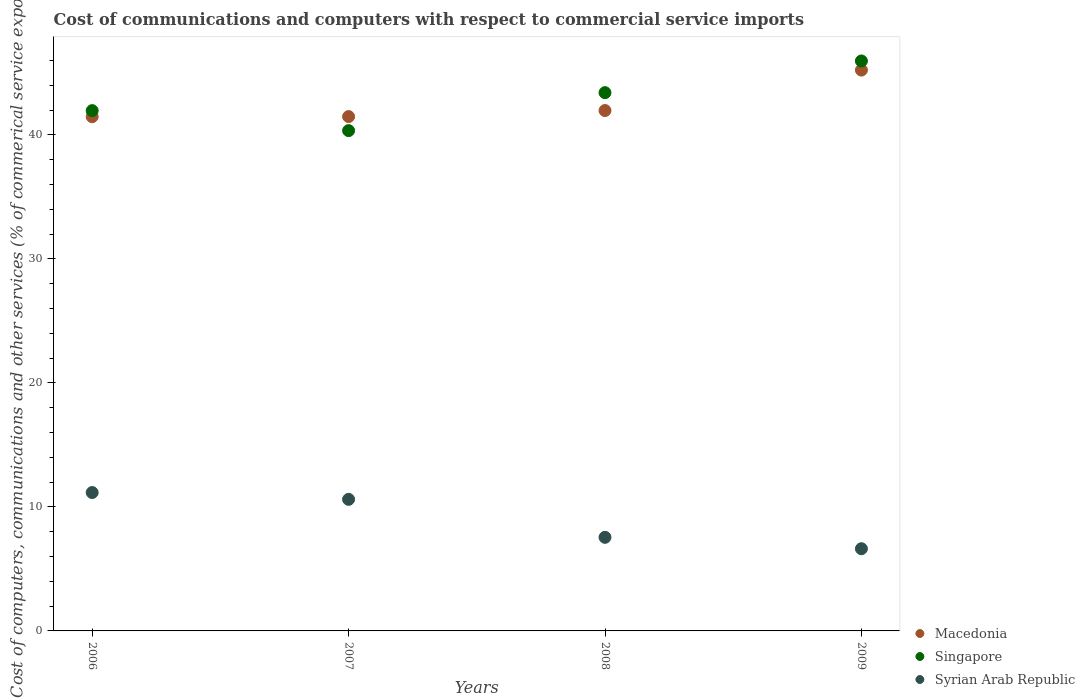How many different coloured dotlines are there?
Your answer should be very brief. 3. Is the number of dotlines equal to the number of legend labels?
Keep it short and to the point. Yes. What is the cost of communications and computers in Singapore in 2006?
Your answer should be compact. 41.96. Across all years, what is the maximum cost of communications and computers in Macedonia?
Your answer should be very brief. 45.23. Across all years, what is the minimum cost of communications and computers in Syrian Arab Republic?
Your response must be concise. 6.63. In which year was the cost of communications and computers in Singapore maximum?
Keep it short and to the point. 2009. What is the total cost of communications and computers in Syrian Arab Republic in the graph?
Give a very brief answer. 35.95. What is the difference between the cost of communications and computers in Macedonia in 2006 and that in 2009?
Your response must be concise. -3.76. What is the difference between the cost of communications and computers in Macedonia in 2006 and the cost of communications and computers in Singapore in 2008?
Keep it short and to the point. -1.94. What is the average cost of communications and computers in Macedonia per year?
Offer a terse response. 42.54. In the year 2007, what is the difference between the cost of communications and computers in Singapore and cost of communications and computers in Syrian Arab Republic?
Give a very brief answer. 29.74. What is the ratio of the cost of communications and computers in Syrian Arab Republic in 2006 to that in 2008?
Your response must be concise. 1.48. Is the cost of communications and computers in Syrian Arab Republic in 2006 less than that in 2009?
Your answer should be very brief. No. What is the difference between the highest and the second highest cost of communications and computers in Singapore?
Offer a terse response. 2.56. What is the difference between the highest and the lowest cost of communications and computers in Singapore?
Keep it short and to the point. 5.62. Is the sum of the cost of communications and computers in Macedonia in 2008 and 2009 greater than the maximum cost of communications and computers in Syrian Arab Republic across all years?
Ensure brevity in your answer.  Yes. Is it the case that in every year, the sum of the cost of communications and computers in Syrian Arab Republic and cost of communications and computers in Macedonia  is greater than the cost of communications and computers in Singapore?
Provide a short and direct response. Yes. Is the cost of communications and computers in Syrian Arab Republic strictly less than the cost of communications and computers in Macedonia over the years?
Your answer should be very brief. Yes. How many dotlines are there?
Your answer should be compact. 3. Are the values on the major ticks of Y-axis written in scientific E-notation?
Your response must be concise. No. Does the graph contain any zero values?
Ensure brevity in your answer.  No. Does the graph contain grids?
Give a very brief answer. No. Where does the legend appear in the graph?
Give a very brief answer. Bottom right. How many legend labels are there?
Give a very brief answer. 3. What is the title of the graph?
Your answer should be very brief. Cost of communications and computers with respect to commercial service imports. What is the label or title of the X-axis?
Offer a terse response. Years. What is the label or title of the Y-axis?
Ensure brevity in your answer.  Cost of computers, communications and other services (% of commerical service exports). What is the Cost of computers, communications and other services (% of commerical service exports) in Macedonia in 2006?
Keep it short and to the point. 41.47. What is the Cost of computers, communications and other services (% of commerical service exports) of Singapore in 2006?
Offer a very short reply. 41.96. What is the Cost of computers, communications and other services (% of commerical service exports) of Syrian Arab Republic in 2006?
Provide a succinct answer. 11.16. What is the Cost of computers, communications and other services (% of commerical service exports) of Macedonia in 2007?
Provide a short and direct response. 41.48. What is the Cost of computers, communications and other services (% of commerical service exports) in Singapore in 2007?
Keep it short and to the point. 40.35. What is the Cost of computers, communications and other services (% of commerical service exports) in Syrian Arab Republic in 2007?
Make the answer very short. 10.61. What is the Cost of computers, communications and other services (% of commerical service exports) of Macedonia in 2008?
Keep it short and to the point. 41.97. What is the Cost of computers, communications and other services (% of commerical service exports) of Singapore in 2008?
Keep it short and to the point. 43.41. What is the Cost of computers, communications and other services (% of commerical service exports) of Syrian Arab Republic in 2008?
Give a very brief answer. 7.55. What is the Cost of computers, communications and other services (% of commerical service exports) in Macedonia in 2009?
Provide a succinct answer. 45.23. What is the Cost of computers, communications and other services (% of commerical service exports) of Singapore in 2009?
Your answer should be very brief. 45.97. What is the Cost of computers, communications and other services (% of commerical service exports) in Syrian Arab Republic in 2009?
Make the answer very short. 6.63. Across all years, what is the maximum Cost of computers, communications and other services (% of commerical service exports) of Macedonia?
Make the answer very short. 45.23. Across all years, what is the maximum Cost of computers, communications and other services (% of commerical service exports) in Singapore?
Provide a short and direct response. 45.97. Across all years, what is the maximum Cost of computers, communications and other services (% of commerical service exports) of Syrian Arab Republic?
Offer a terse response. 11.16. Across all years, what is the minimum Cost of computers, communications and other services (% of commerical service exports) in Macedonia?
Make the answer very short. 41.47. Across all years, what is the minimum Cost of computers, communications and other services (% of commerical service exports) of Singapore?
Offer a very short reply. 40.35. Across all years, what is the minimum Cost of computers, communications and other services (% of commerical service exports) of Syrian Arab Republic?
Your answer should be compact. 6.63. What is the total Cost of computers, communications and other services (% of commerical service exports) in Macedonia in the graph?
Give a very brief answer. 170.15. What is the total Cost of computers, communications and other services (% of commerical service exports) in Singapore in the graph?
Provide a succinct answer. 171.69. What is the total Cost of computers, communications and other services (% of commerical service exports) in Syrian Arab Republic in the graph?
Your response must be concise. 35.95. What is the difference between the Cost of computers, communications and other services (% of commerical service exports) of Macedonia in 2006 and that in 2007?
Your answer should be very brief. -0.01. What is the difference between the Cost of computers, communications and other services (% of commerical service exports) in Singapore in 2006 and that in 2007?
Give a very brief answer. 1.61. What is the difference between the Cost of computers, communications and other services (% of commerical service exports) in Syrian Arab Republic in 2006 and that in 2007?
Offer a terse response. 0.55. What is the difference between the Cost of computers, communications and other services (% of commerical service exports) of Macedonia in 2006 and that in 2008?
Offer a very short reply. -0.49. What is the difference between the Cost of computers, communications and other services (% of commerical service exports) of Singapore in 2006 and that in 2008?
Offer a terse response. -1.45. What is the difference between the Cost of computers, communications and other services (% of commerical service exports) in Syrian Arab Republic in 2006 and that in 2008?
Keep it short and to the point. 3.61. What is the difference between the Cost of computers, communications and other services (% of commerical service exports) in Macedonia in 2006 and that in 2009?
Give a very brief answer. -3.76. What is the difference between the Cost of computers, communications and other services (% of commerical service exports) of Singapore in 2006 and that in 2009?
Your answer should be very brief. -4.01. What is the difference between the Cost of computers, communications and other services (% of commerical service exports) in Syrian Arab Republic in 2006 and that in 2009?
Your answer should be very brief. 4.53. What is the difference between the Cost of computers, communications and other services (% of commerical service exports) in Macedonia in 2007 and that in 2008?
Ensure brevity in your answer.  -0.49. What is the difference between the Cost of computers, communications and other services (% of commerical service exports) of Singapore in 2007 and that in 2008?
Make the answer very short. -3.06. What is the difference between the Cost of computers, communications and other services (% of commerical service exports) in Syrian Arab Republic in 2007 and that in 2008?
Your answer should be very brief. 3.06. What is the difference between the Cost of computers, communications and other services (% of commerical service exports) of Macedonia in 2007 and that in 2009?
Ensure brevity in your answer.  -3.75. What is the difference between the Cost of computers, communications and other services (% of commerical service exports) in Singapore in 2007 and that in 2009?
Provide a succinct answer. -5.62. What is the difference between the Cost of computers, communications and other services (% of commerical service exports) of Syrian Arab Republic in 2007 and that in 2009?
Provide a short and direct response. 3.98. What is the difference between the Cost of computers, communications and other services (% of commerical service exports) of Macedonia in 2008 and that in 2009?
Keep it short and to the point. -3.26. What is the difference between the Cost of computers, communications and other services (% of commerical service exports) of Singapore in 2008 and that in 2009?
Ensure brevity in your answer.  -2.56. What is the difference between the Cost of computers, communications and other services (% of commerical service exports) of Syrian Arab Republic in 2008 and that in 2009?
Your answer should be compact. 0.92. What is the difference between the Cost of computers, communications and other services (% of commerical service exports) in Macedonia in 2006 and the Cost of computers, communications and other services (% of commerical service exports) in Singapore in 2007?
Keep it short and to the point. 1.12. What is the difference between the Cost of computers, communications and other services (% of commerical service exports) in Macedonia in 2006 and the Cost of computers, communications and other services (% of commerical service exports) in Syrian Arab Republic in 2007?
Provide a short and direct response. 30.86. What is the difference between the Cost of computers, communications and other services (% of commerical service exports) of Singapore in 2006 and the Cost of computers, communications and other services (% of commerical service exports) of Syrian Arab Republic in 2007?
Ensure brevity in your answer.  31.35. What is the difference between the Cost of computers, communications and other services (% of commerical service exports) of Macedonia in 2006 and the Cost of computers, communications and other services (% of commerical service exports) of Singapore in 2008?
Provide a succinct answer. -1.94. What is the difference between the Cost of computers, communications and other services (% of commerical service exports) in Macedonia in 2006 and the Cost of computers, communications and other services (% of commerical service exports) in Syrian Arab Republic in 2008?
Provide a succinct answer. 33.93. What is the difference between the Cost of computers, communications and other services (% of commerical service exports) in Singapore in 2006 and the Cost of computers, communications and other services (% of commerical service exports) in Syrian Arab Republic in 2008?
Provide a succinct answer. 34.41. What is the difference between the Cost of computers, communications and other services (% of commerical service exports) of Macedonia in 2006 and the Cost of computers, communications and other services (% of commerical service exports) of Singapore in 2009?
Your answer should be compact. -4.49. What is the difference between the Cost of computers, communications and other services (% of commerical service exports) of Macedonia in 2006 and the Cost of computers, communications and other services (% of commerical service exports) of Syrian Arab Republic in 2009?
Keep it short and to the point. 34.84. What is the difference between the Cost of computers, communications and other services (% of commerical service exports) in Singapore in 2006 and the Cost of computers, communications and other services (% of commerical service exports) in Syrian Arab Republic in 2009?
Your answer should be very brief. 35.33. What is the difference between the Cost of computers, communications and other services (% of commerical service exports) of Macedonia in 2007 and the Cost of computers, communications and other services (% of commerical service exports) of Singapore in 2008?
Provide a short and direct response. -1.93. What is the difference between the Cost of computers, communications and other services (% of commerical service exports) in Macedonia in 2007 and the Cost of computers, communications and other services (% of commerical service exports) in Syrian Arab Republic in 2008?
Provide a succinct answer. 33.93. What is the difference between the Cost of computers, communications and other services (% of commerical service exports) of Singapore in 2007 and the Cost of computers, communications and other services (% of commerical service exports) of Syrian Arab Republic in 2008?
Give a very brief answer. 32.8. What is the difference between the Cost of computers, communications and other services (% of commerical service exports) in Macedonia in 2007 and the Cost of computers, communications and other services (% of commerical service exports) in Singapore in 2009?
Provide a short and direct response. -4.49. What is the difference between the Cost of computers, communications and other services (% of commerical service exports) in Macedonia in 2007 and the Cost of computers, communications and other services (% of commerical service exports) in Syrian Arab Republic in 2009?
Provide a succinct answer. 34.85. What is the difference between the Cost of computers, communications and other services (% of commerical service exports) in Singapore in 2007 and the Cost of computers, communications and other services (% of commerical service exports) in Syrian Arab Republic in 2009?
Provide a short and direct response. 33.72. What is the difference between the Cost of computers, communications and other services (% of commerical service exports) in Macedonia in 2008 and the Cost of computers, communications and other services (% of commerical service exports) in Singapore in 2009?
Offer a very short reply. -4. What is the difference between the Cost of computers, communications and other services (% of commerical service exports) of Macedonia in 2008 and the Cost of computers, communications and other services (% of commerical service exports) of Syrian Arab Republic in 2009?
Provide a succinct answer. 35.34. What is the difference between the Cost of computers, communications and other services (% of commerical service exports) of Singapore in 2008 and the Cost of computers, communications and other services (% of commerical service exports) of Syrian Arab Republic in 2009?
Ensure brevity in your answer.  36.78. What is the average Cost of computers, communications and other services (% of commerical service exports) in Macedonia per year?
Provide a short and direct response. 42.54. What is the average Cost of computers, communications and other services (% of commerical service exports) of Singapore per year?
Give a very brief answer. 42.92. What is the average Cost of computers, communications and other services (% of commerical service exports) of Syrian Arab Republic per year?
Offer a very short reply. 8.99. In the year 2006, what is the difference between the Cost of computers, communications and other services (% of commerical service exports) in Macedonia and Cost of computers, communications and other services (% of commerical service exports) in Singapore?
Provide a short and direct response. -0.49. In the year 2006, what is the difference between the Cost of computers, communications and other services (% of commerical service exports) in Macedonia and Cost of computers, communications and other services (% of commerical service exports) in Syrian Arab Republic?
Ensure brevity in your answer.  30.31. In the year 2006, what is the difference between the Cost of computers, communications and other services (% of commerical service exports) in Singapore and Cost of computers, communications and other services (% of commerical service exports) in Syrian Arab Republic?
Keep it short and to the point. 30.8. In the year 2007, what is the difference between the Cost of computers, communications and other services (% of commerical service exports) in Macedonia and Cost of computers, communications and other services (% of commerical service exports) in Singapore?
Offer a very short reply. 1.13. In the year 2007, what is the difference between the Cost of computers, communications and other services (% of commerical service exports) in Macedonia and Cost of computers, communications and other services (% of commerical service exports) in Syrian Arab Republic?
Provide a short and direct response. 30.87. In the year 2007, what is the difference between the Cost of computers, communications and other services (% of commerical service exports) in Singapore and Cost of computers, communications and other services (% of commerical service exports) in Syrian Arab Republic?
Keep it short and to the point. 29.74. In the year 2008, what is the difference between the Cost of computers, communications and other services (% of commerical service exports) of Macedonia and Cost of computers, communications and other services (% of commerical service exports) of Singapore?
Keep it short and to the point. -1.44. In the year 2008, what is the difference between the Cost of computers, communications and other services (% of commerical service exports) of Macedonia and Cost of computers, communications and other services (% of commerical service exports) of Syrian Arab Republic?
Make the answer very short. 34.42. In the year 2008, what is the difference between the Cost of computers, communications and other services (% of commerical service exports) in Singapore and Cost of computers, communications and other services (% of commerical service exports) in Syrian Arab Republic?
Keep it short and to the point. 35.86. In the year 2009, what is the difference between the Cost of computers, communications and other services (% of commerical service exports) of Macedonia and Cost of computers, communications and other services (% of commerical service exports) of Singapore?
Your response must be concise. -0.74. In the year 2009, what is the difference between the Cost of computers, communications and other services (% of commerical service exports) in Macedonia and Cost of computers, communications and other services (% of commerical service exports) in Syrian Arab Republic?
Give a very brief answer. 38.6. In the year 2009, what is the difference between the Cost of computers, communications and other services (% of commerical service exports) in Singapore and Cost of computers, communications and other services (% of commerical service exports) in Syrian Arab Republic?
Ensure brevity in your answer.  39.34. What is the ratio of the Cost of computers, communications and other services (% of commerical service exports) of Singapore in 2006 to that in 2007?
Your answer should be compact. 1.04. What is the ratio of the Cost of computers, communications and other services (% of commerical service exports) in Syrian Arab Republic in 2006 to that in 2007?
Make the answer very short. 1.05. What is the ratio of the Cost of computers, communications and other services (% of commerical service exports) of Singapore in 2006 to that in 2008?
Offer a very short reply. 0.97. What is the ratio of the Cost of computers, communications and other services (% of commerical service exports) of Syrian Arab Republic in 2006 to that in 2008?
Your response must be concise. 1.48. What is the ratio of the Cost of computers, communications and other services (% of commerical service exports) of Macedonia in 2006 to that in 2009?
Make the answer very short. 0.92. What is the ratio of the Cost of computers, communications and other services (% of commerical service exports) in Singapore in 2006 to that in 2009?
Offer a terse response. 0.91. What is the ratio of the Cost of computers, communications and other services (% of commerical service exports) of Syrian Arab Republic in 2006 to that in 2009?
Your answer should be compact. 1.68. What is the ratio of the Cost of computers, communications and other services (% of commerical service exports) of Macedonia in 2007 to that in 2008?
Give a very brief answer. 0.99. What is the ratio of the Cost of computers, communications and other services (% of commerical service exports) in Singapore in 2007 to that in 2008?
Provide a succinct answer. 0.93. What is the ratio of the Cost of computers, communications and other services (% of commerical service exports) in Syrian Arab Republic in 2007 to that in 2008?
Offer a terse response. 1.41. What is the ratio of the Cost of computers, communications and other services (% of commerical service exports) in Macedonia in 2007 to that in 2009?
Provide a succinct answer. 0.92. What is the ratio of the Cost of computers, communications and other services (% of commerical service exports) in Singapore in 2007 to that in 2009?
Offer a very short reply. 0.88. What is the ratio of the Cost of computers, communications and other services (% of commerical service exports) of Syrian Arab Republic in 2007 to that in 2009?
Make the answer very short. 1.6. What is the ratio of the Cost of computers, communications and other services (% of commerical service exports) in Macedonia in 2008 to that in 2009?
Your response must be concise. 0.93. What is the ratio of the Cost of computers, communications and other services (% of commerical service exports) of Syrian Arab Republic in 2008 to that in 2009?
Provide a succinct answer. 1.14. What is the difference between the highest and the second highest Cost of computers, communications and other services (% of commerical service exports) in Macedonia?
Offer a terse response. 3.26. What is the difference between the highest and the second highest Cost of computers, communications and other services (% of commerical service exports) of Singapore?
Offer a very short reply. 2.56. What is the difference between the highest and the second highest Cost of computers, communications and other services (% of commerical service exports) of Syrian Arab Republic?
Your answer should be compact. 0.55. What is the difference between the highest and the lowest Cost of computers, communications and other services (% of commerical service exports) of Macedonia?
Offer a terse response. 3.76. What is the difference between the highest and the lowest Cost of computers, communications and other services (% of commerical service exports) of Singapore?
Offer a terse response. 5.62. What is the difference between the highest and the lowest Cost of computers, communications and other services (% of commerical service exports) of Syrian Arab Republic?
Give a very brief answer. 4.53. 